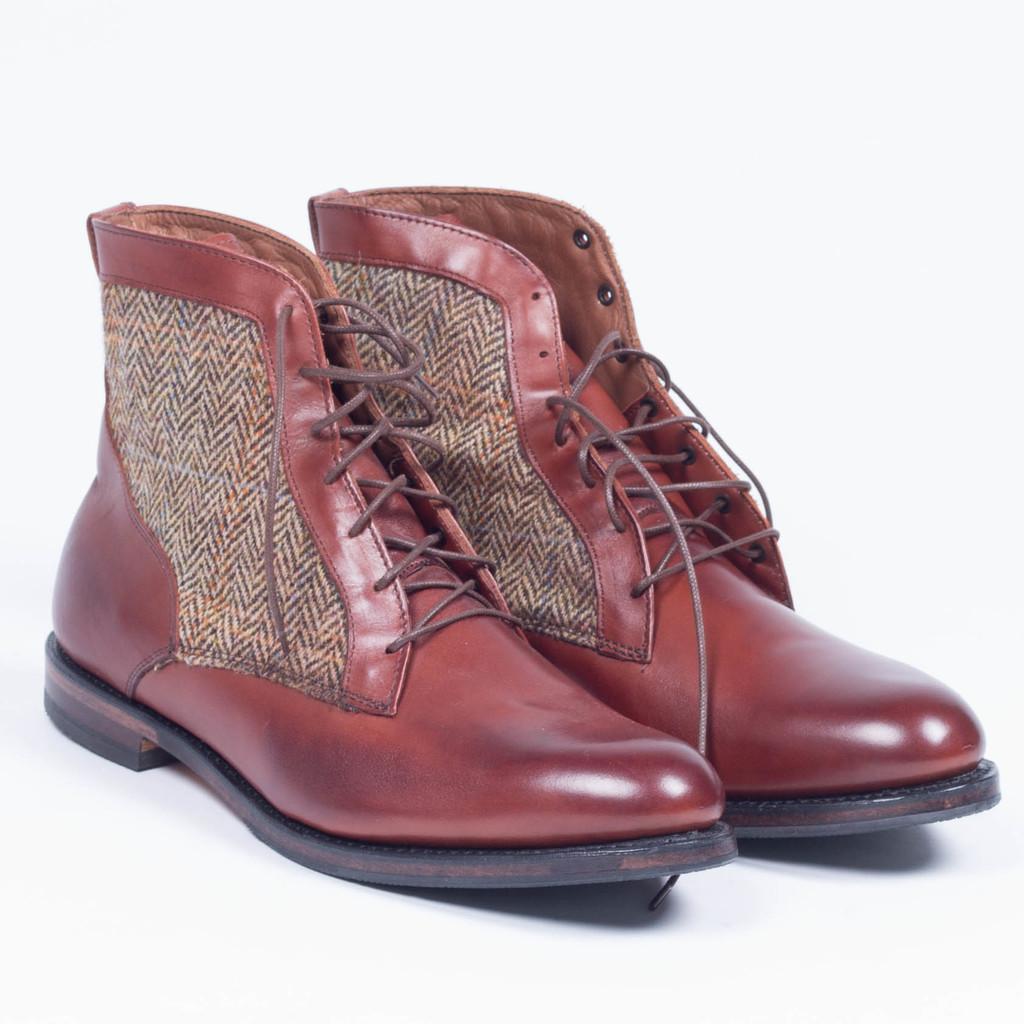How would you summarize this image in a sentence or two? In this picture we can observe a pair of shoes which were in brown color placed on the white color surface. The background is in white color. 